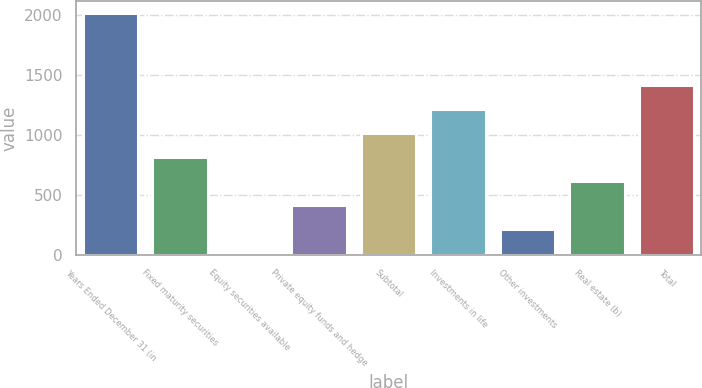<chart> <loc_0><loc_0><loc_500><loc_500><bar_chart><fcel>Years Ended December 31 (in<fcel>Fixed maturity securities<fcel>Equity securities available<fcel>Private equity funds and hedge<fcel>Subtotal<fcel>Investments in life<fcel>Other investments<fcel>Real estate (b)<fcel>Total<nl><fcel>2017<fcel>813.4<fcel>11<fcel>412.2<fcel>1014<fcel>1214.6<fcel>211.6<fcel>612.8<fcel>1415.2<nl></chart> 